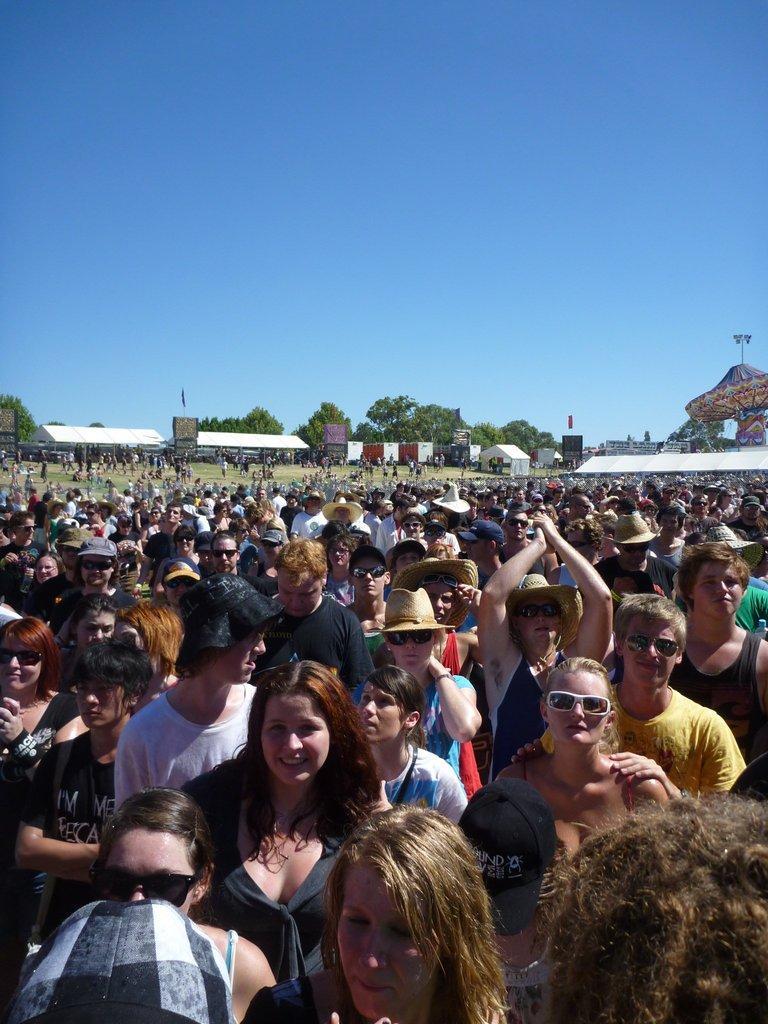Describe this image in one or two sentences. There is a crowd at the bottom of this image. We can see trees and shelters in the middle of this image and the sky is in the background. 